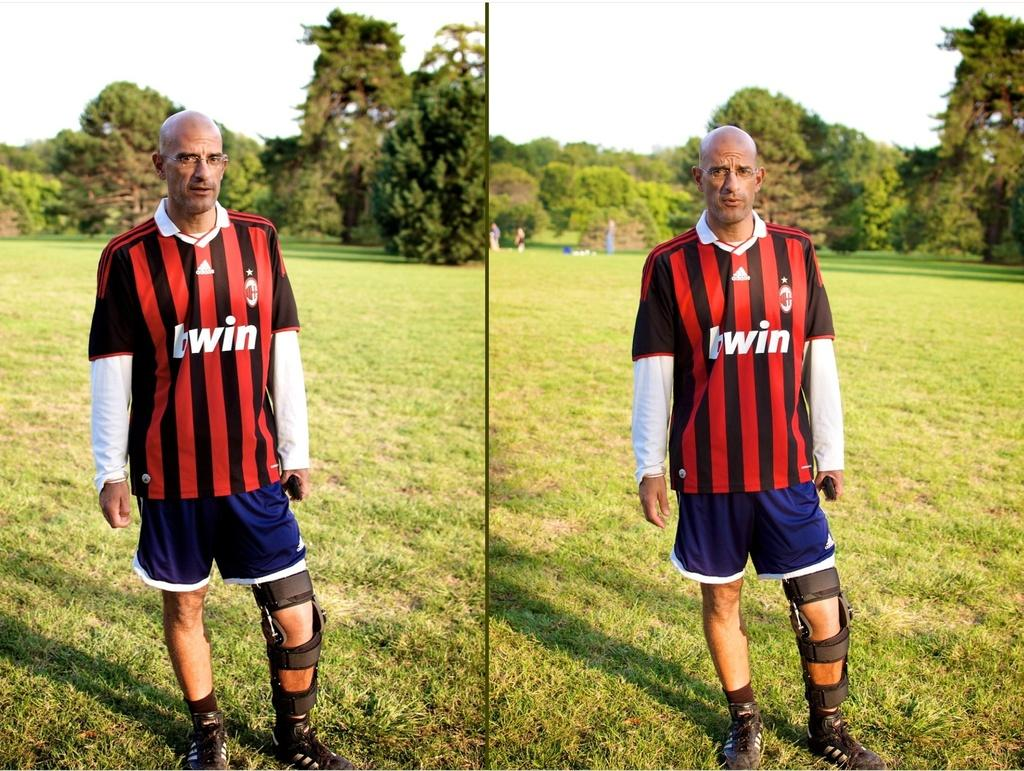<image>
Share a concise interpretation of the image provided. An older bald man wears a striped TWIN athletic uniform. 